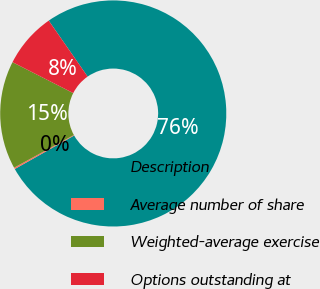Convert chart to OTSL. <chart><loc_0><loc_0><loc_500><loc_500><pie_chart><fcel>Description<fcel>Average number of share<fcel>Weighted-average exercise<fcel>Options outstanding at<nl><fcel>76.49%<fcel>0.21%<fcel>15.46%<fcel>7.84%<nl></chart> 